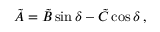<formula> <loc_0><loc_0><loc_500><loc_500>\tilde { A } = \tilde { B } \sin \delta - \tilde { C } \cos \delta \, ,</formula> 